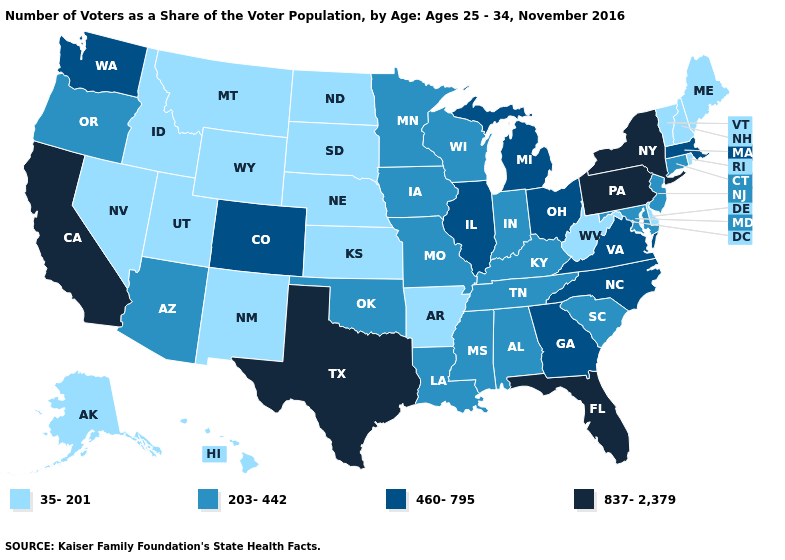What is the lowest value in states that border South Carolina?
Keep it brief. 460-795. Which states hav the highest value in the Northeast?
Keep it brief. New York, Pennsylvania. What is the highest value in the MidWest ?
Keep it brief. 460-795. What is the lowest value in the Northeast?
Concise answer only. 35-201. Does the first symbol in the legend represent the smallest category?
Quick response, please. Yes. Does Alabama have the same value as Kentucky?
Be succinct. Yes. What is the highest value in the USA?
Quick response, please. 837-2,379. What is the lowest value in the USA?
Give a very brief answer. 35-201. What is the value of Colorado?
Keep it brief. 460-795. What is the lowest value in the USA?
Answer briefly. 35-201. What is the highest value in states that border South Carolina?
Write a very short answer. 460-795. Name the states that have a value in the range 35-201?
Keep it brief. Alaska, Arkansas, Delaware, Hawaii, Idaho, Kansas, Maine, Montana, Nebraska, Nevada, New Hampshire, New Mexico, North Dakota, Rhode Island, South Dakota, Utah, Vermont, West Virginia, Wyoming. What is the value of Alabama?
Keep it brief. 203-442. Among the states that border Connecticut , does Rhode Island have the lowest value?
Write a very short answer. Yes. Which states hav the highest value in the Northeast?
Concise answer only. New York, Pennsylvania. 